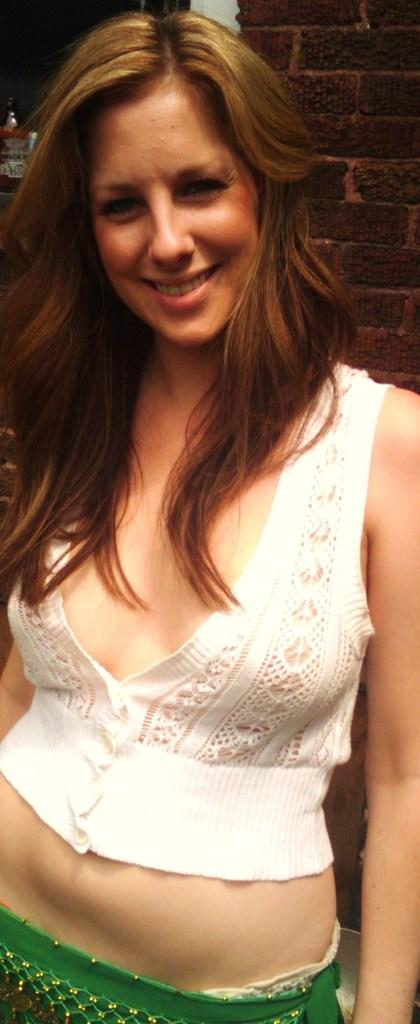What is the main subject of the image? There is a woman in the image. What is the woman doing in the image? The woman is standing in the image. What is the woman's facial expression in the image? The woman is smiling in the image. What can be seen in the background of the image? There is a wall and objects in the background of the image. What type of shirt is the woman wearing in the image? The provided facts do not mention the woman's clothing, so we cannot determine the type of shirt she is wearing. --- Facts: 1. There is a car in the image. 2. The car is red. 3. The car has four wheels. 4. There are people in the car. 5. The car is parked. Absurd Topics: bird, ocean, mountain Conversation: What is the main subject of the image? There is a car in the image. What color is the car? The car is red. How many wheels does the car have? The car has four wheels. Are there any passengers in the car? Yes, there are people in the car. What is the car's current status in the image? The car is parked. Reasoning: Let's think step by step in order to produce the conversation. We start by identifying the main subject of the image, which is the car. Then, we describe the car's color and number of wheels to provide more details about the car. Next, we mention the presence of passengers to give a sense of the car's purpose. Finally, we describe the car's status to provide context about its current situation. Absurd Question/Answer: Can you see any mountains in the background of the image? The provided facts do not mention any mountains in the background of the image. 